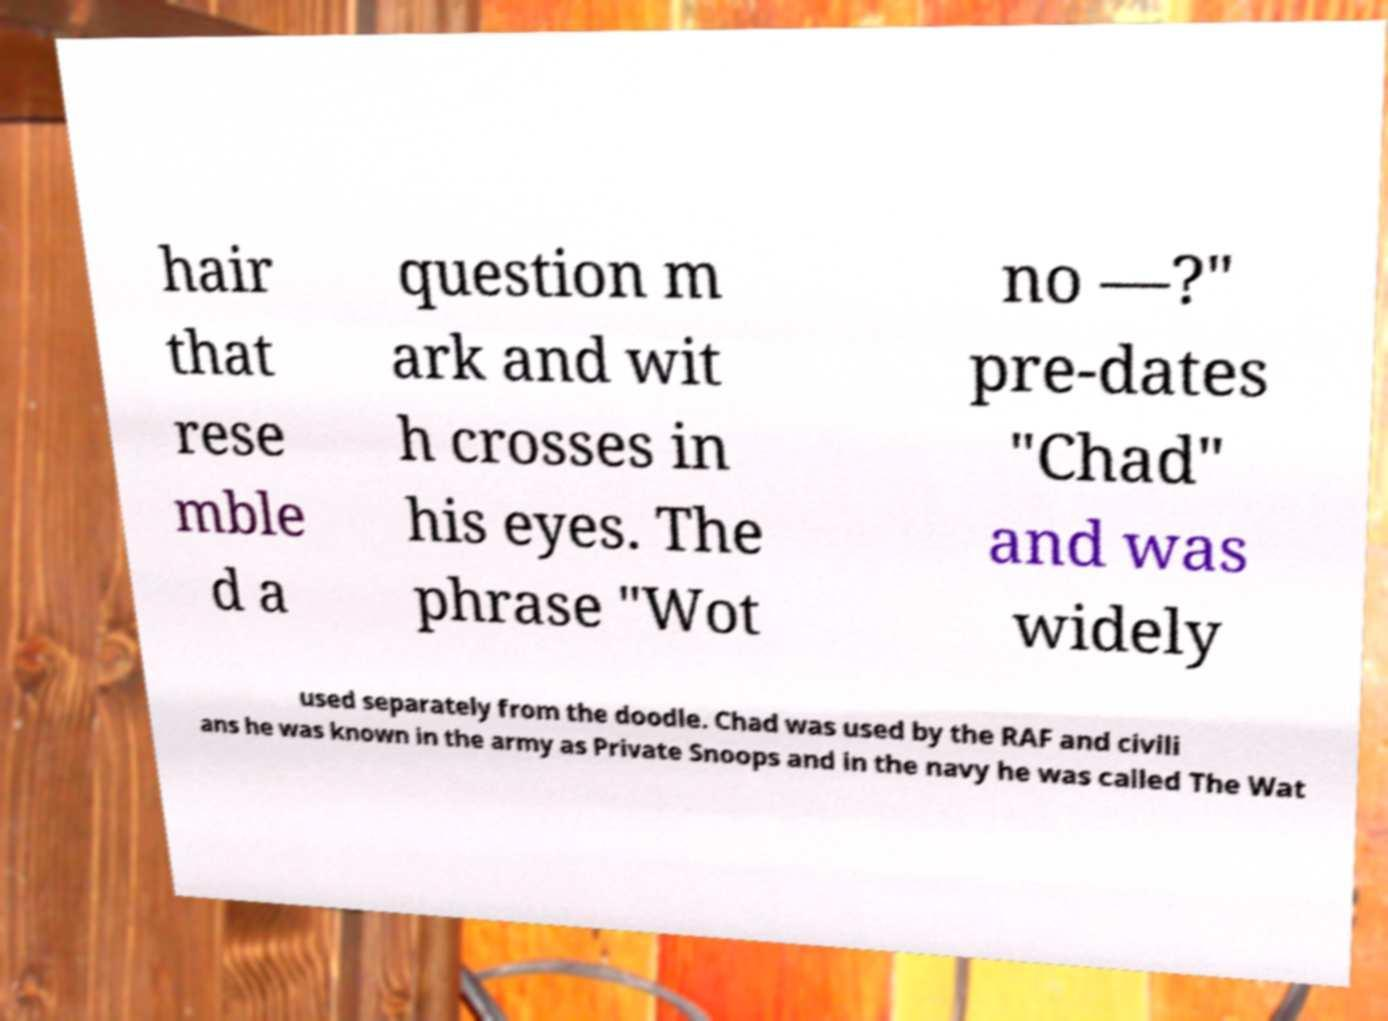Can you accurately transcribe the text from the provided image for me? hair that rese mble d a question m ark and wit h crosses in his eyes. The phrase "Wot no —?" pre-dates "Chad" and was widely used separately from the doodle. Chad was used by the RAF and civili ans he was known in the army as Private Snoops and in the navy he was called The Wat 